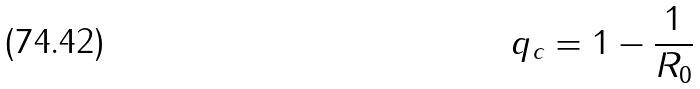Convert formula to latex. <formula><loc_0><loc_0><loc_500><loc_500>q _ { c } = 1 - \frac { 1 } { R _ { 0 } }</formula> 